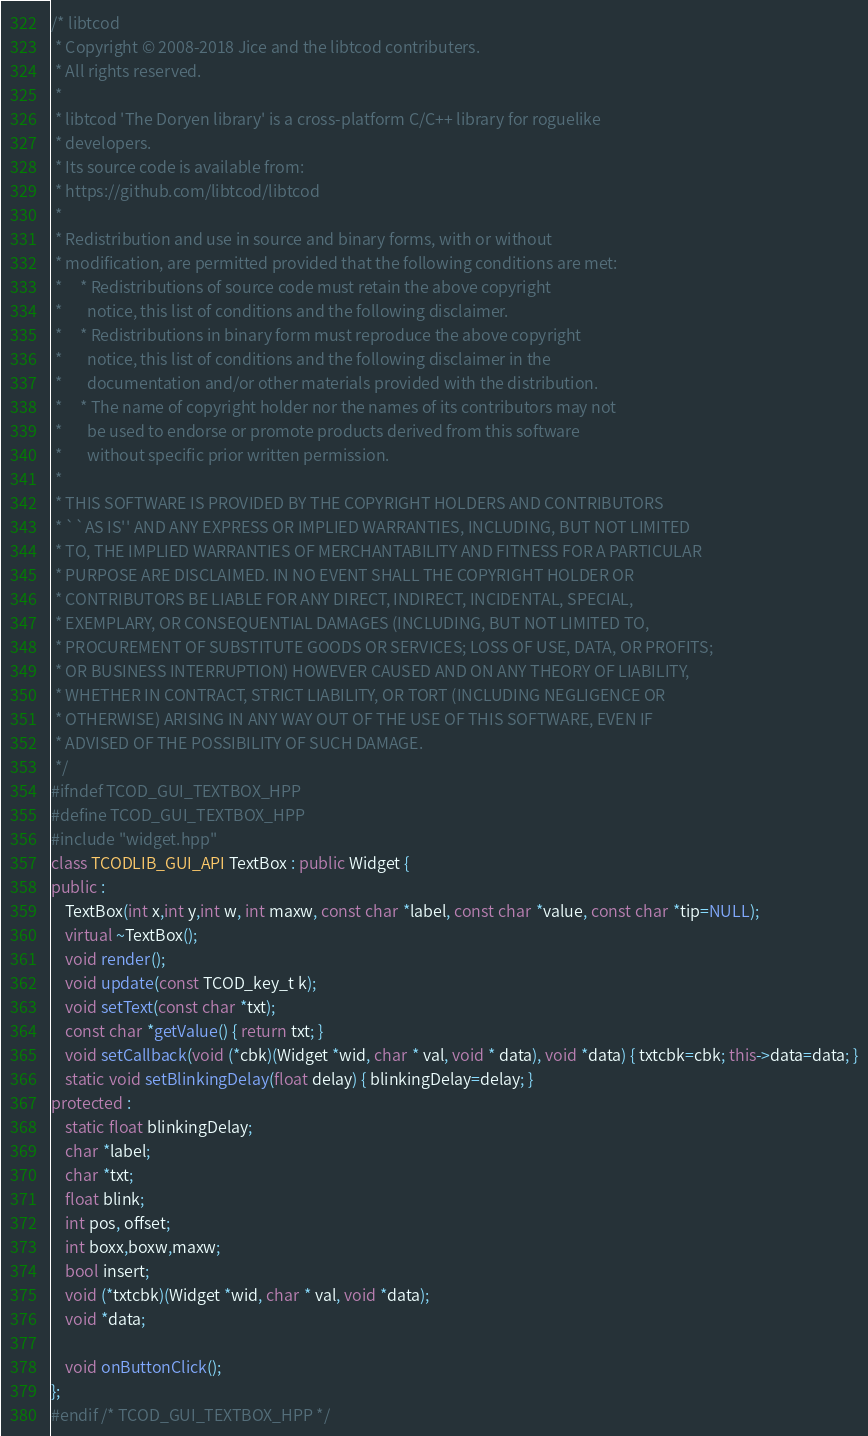<code> <loc_0><loc_0><loc_500><loc_500><_C++_>/* libtcod
 * Copyright © 2008-2018 Jice and the libtcod contributers.
 * All rights reserved.
 *
 * libtcod 'The Doryen library' is a cross-platform C/C++ library for roguelike
 * developers.
 * Its source code is available from:
 * https://github.com/libtcod/libtcod
 *
 * Redistribution and use in source and binary forms, with or without
 * modification, are permitted provided that the following conditions are met:
 *     * Redistributions of source code must retain the above copyright
 *       notice, this list of conditions and the following disclaimer.
 *     * Redistributions in binary form must reproduce the above copyright
 *       notice, this list of conditions and the following disclaimer in the
 *       documentation and/or other materials provided with the distribution.
 *     * The name of copyright holder nor the names of its contributors may not
 *       be used to endorse or promote products derived from this software
 *       without specific prior written permission.
 *
 * THIS SOFTWARE IS PROVIDED BY THE COPYRIGHT HOLDERS AND CONTRIBUTORS
 * ``AS IS'' AND ANY EXPRESS OR IMPLIED WARRANTIES, INCLUDING, BUT NOT LIMITED
 * TO, THE IMPLIED WARRANTIES OF MERCHANTABILITY AND FITNESS FOR A PARTICULAR
 * PURPOSE ARE DISCLAIMED. IN NO EVENT SHALL THE COPYRIGHT HOLDER OR
 * CONTRIBUTORS BE LIABLE FOR ANY DIRECT, INDIRECT, INCIDENTAL, SPECIAL,
 * EXEMPLARY, OR CONSEQUENTIAL DAMAGES (INCLUDING, BUT NOT LIMITED TO,
 * PROCUREMENT OF SUBSTITUTE GOODS OR SERVICES; LOSS OF USE, DATA, OR PROFITS;
 * OR BUSINESS INTERRUPTION) HOWEVER CAUSED AND ON ANY THEORY OF LIABILITY,
 * WHETHER IN CONTRACT, STRICT LIABILITY, OR TORT (INCLUDING NEGLIGENCE OR
 * OTHERWISE) ARISING IN ANY WAY OUT OF THE USE OF THIS SOFTWARE, EVEN IF
 * ADVISED OF THE POSSIBILITY OF SUCH DAMAGE.
 */
#ifndef TCOD_GUI_TEXTBOX_HPP
#define TCOD_GUI_TEXTBOX_HPP
#include "widget.hpp"
class TCODLIB_GUI_API TextBox : public Widget {
public :
	TextBox(int x,int y,int w, int maxw, const char *label, const char *value, const char *tip=NULL);
	virtual ~TextBox();
	void render();
	void update(const TCOD_key_t k);
	void setText(const char *txt);
	const char *getValue() { return txt; }
	void setCallback(void (*cbk)(Widget *wid, char * val, void * data), void *data) { txtcbk=cbk; this->data=data; }
	static void setBlinkingDelay(float delay) { blinkingDelay=delay; }
protected :
	static float blinkingDelay;
	char *label;
	char *txt;
	float blink;
	int pos, offset;
	int boxx,boxw,maxw;
	bool insert;
	void (*txtcbk)(Widget *wid, char * val, void *data);
	void *data;

	void onButtonClick();
};
#endif /* TCOD_GUI_TEXTBOX_HPP */
</code> 